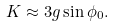<formula> <loc_0><loc_0><loc_500><loc_500>K \approx 3 g \sin \phi _ { 0 } .</formula> 